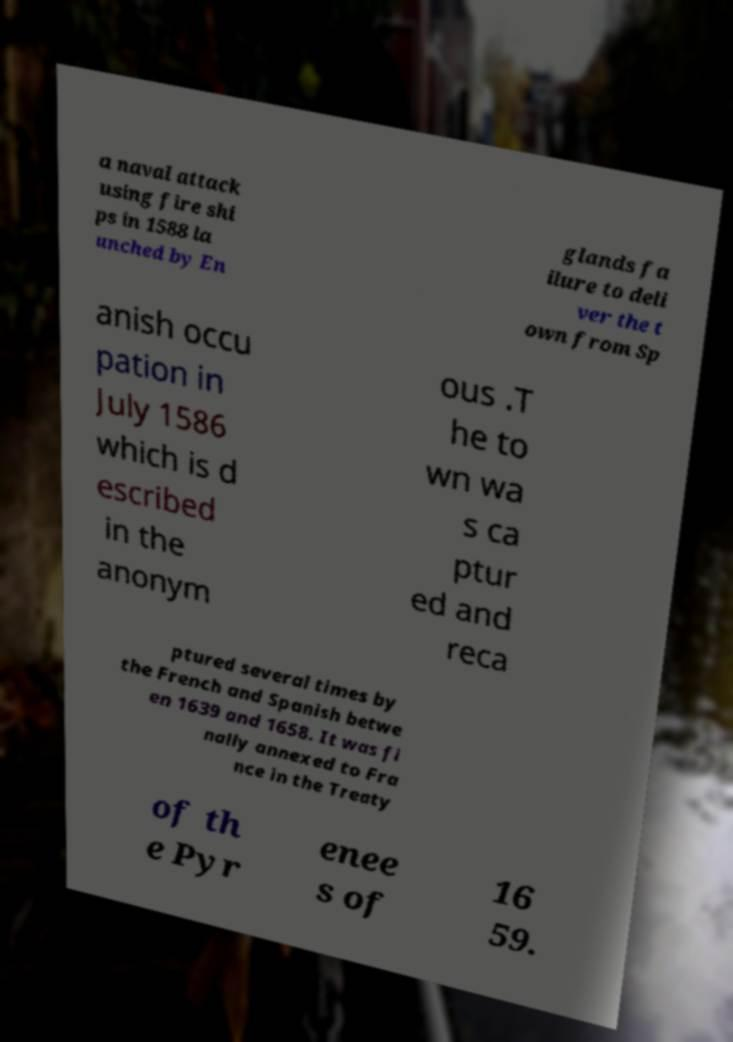I need the written content from this picture converted into text. Can you do that? a naval attack using fire shi ps in 1588 la unched by En glands fa ilure to deli ver the t own from Sp anish occu pation in July 1586 which is d escribed in the anonym ous .T he to wn wa s ca ptur ed and reca ptured several times by the French and Spanish betwe en 1639 and 1658. It was fi nally annexed to Fra nce in the Treaty of th e Pyr enee s of 16 59. 